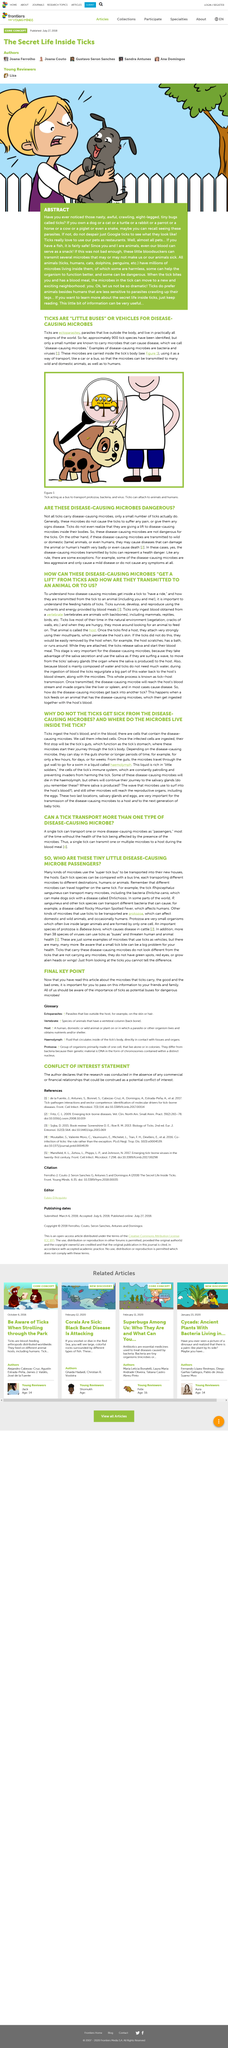Point out several critical features in this image. It is not possible to determine if a tick is carrying disease-causing microorganisms by simply observing it visually. Protozoa are made up of only one cell, with no additional cells present. Yes, ticks are capable of attaching to humans. Ticks survive, develop, and reproduce by using the nutrients and energy provided by blood meals. The tick's salivary glands are the organs where saliva is produced, specifically in ticks. 